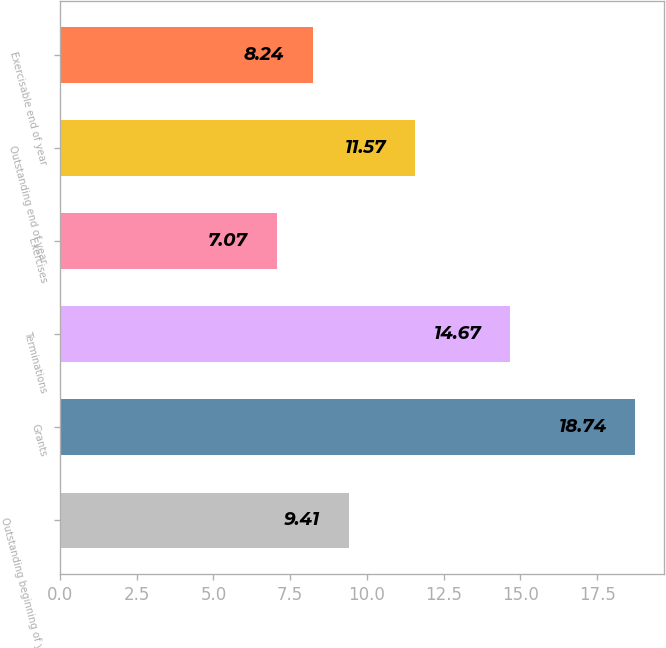<chart> <loc_0><loc_0><loc_500><loc_500><bar_chart><fcel>Outstanding beginning of year<fcel>Grants<fcel>Terminations<fcel>Exercises<fcel>Outstanding end of year<fcel>Exercisable end of year<nl><fcel>9.41<fcel>18.74<fcel>14.67<fcel>7.07<fcel>11.57<fcel>8.24<nl></chart> 